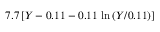<formula> <loc_0><loc_0><loc_500><loc_500>7 . 7 \, [ Y - 0 . 1 1 - 0 . 1 1 \, \ln { ( Y / 0 . 1 1 ) } ]</formula> 